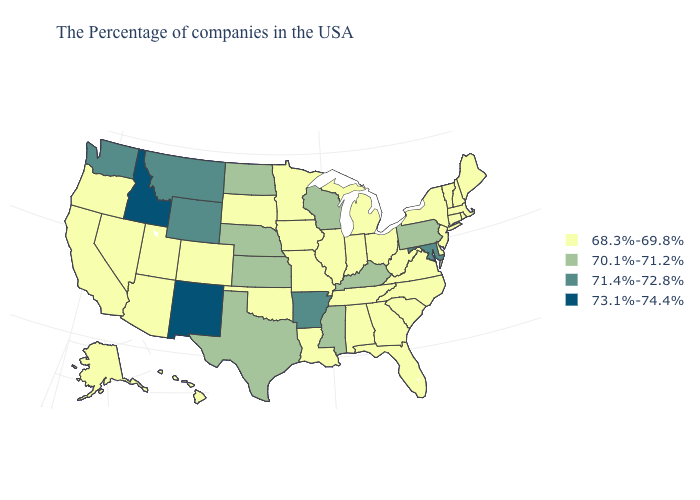How many symbols are there in the legend?
Quick response, please. 4. What is the lowest value in the USA?
Write a very short answer. 68.3%-69.8%. What is the value of Colorado?
Answer briefly. 68.3%-69.8%. Does Rhode Island have the highest value in the Northeast?
Keep it brief. No. Name the states that have a value in the range 68.3%-69.8%?
Give a very brief answer. Maine, Massachusetts, Rhode Island, New Hampshire, Vermont, Connecticut, New York, New Jersey, Delaware, Virginia, North Carolina, South Carolina, West Virginia, Ohio, Florida, Georgia, Michigan, Indiana, Alabama, Tennessee, Illinois, Louisiana, Missouri, Minnesota, Iowa, Oklahoma, South Dakota, Colorado, Utah, Arizona, Nevada, California, Oregon, Alaska, Hawaii. Among the states that border Utah , which have the lowest value?
Keep it brief. Colorado, Arizona, Nevada. Which states have the lowest value in the Northeast?
Write a very short answer. Maine, Massachusetts, Rhode Island, New Hampshire, Vermont, Connecticut, New York, New Jersey. What is the lowest value in the Northeast?
Write a very short answer. 68.3%-69.8%. Name the states that have a value in the range 71.4%-72.8%?
Short answer required. Maryland, Arkansas, Wyoming, Montana, Washington. Does West Virginia have a lower value than Wisconsin?
Be succinct. Yes. Name the states that have a value in the range 73.1%-74.4%?
Quick response, please. New Mexico, Idaho. What is the value of Mississippi?
Keep it brief. 70.1%-71.2%. Name the states that have a value in the range 70.1%-71.2%?
Quick response, please. Pennsylvania, Kentucky, Wisconsin, Mississippi, Kansas, Nebraska, Texas, North Dakota. Does Idaho have the highest value in the USA?
Answer briefly. Yes. Which states have the lowest value in the USA?
Concise answer only. Maine, Massachusetts, Rhode Island, New Hampshire, Vermont, Connecticut, New York, New Jersey, Delaware, Virginia, North Carolina, South Carolina, West Virginia, Ohio, Florida, Georgia, Michigan, Indiana, Alabama, Tennessee, Illinois, Louisiana, Missouri, Minnesota, Iowa, Oklahoma, South Dakota, Colorado, Utah, Arizona, Nevada, California, Oregon, Alaska, Hawaii. 